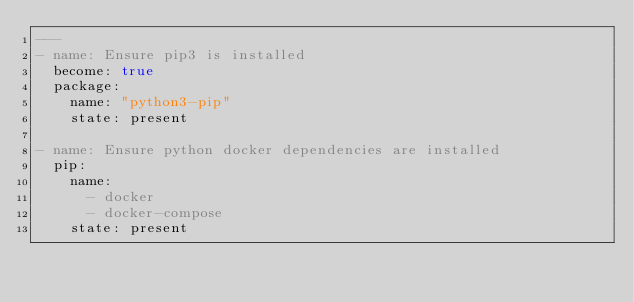<code> <loc_0><loc_0><loc_500><loc_500><_YAML_>---
- name: Ensure pip3 is installed
  become: true
  package:
    name: "python3-pip"
    state: present

- name: Ensure python docker dependencies are installed
  pip:
    name:
      - docker
      - docker-compose
    state: present
</code> 